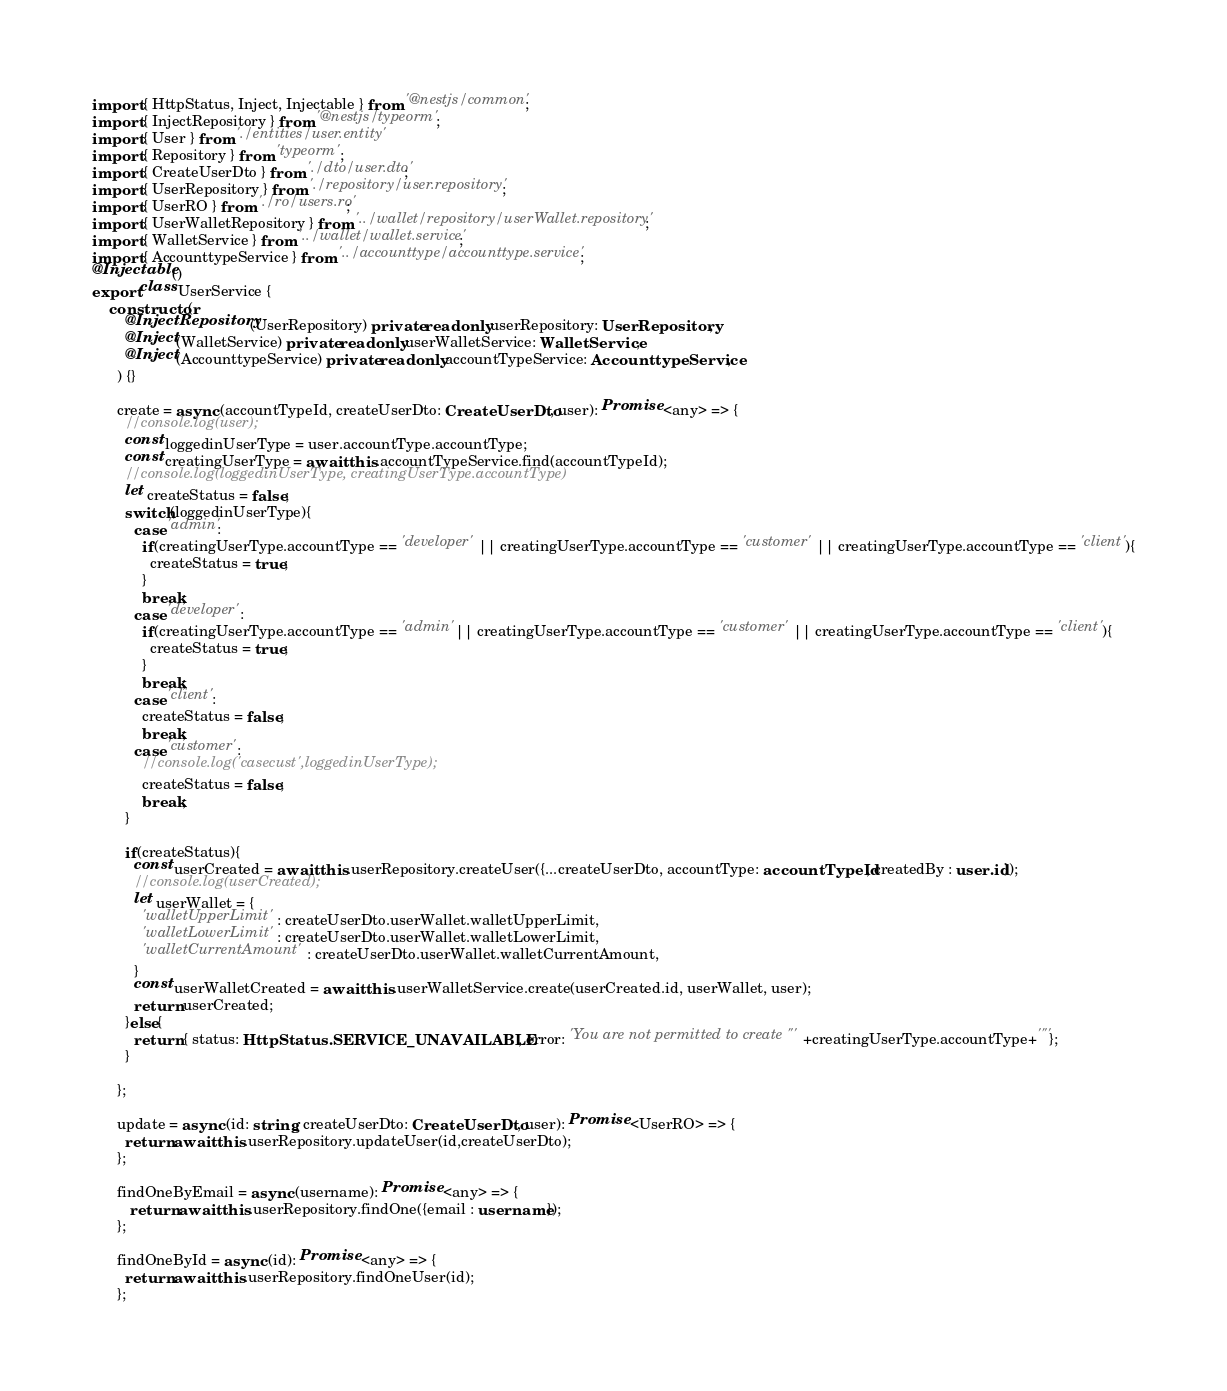<code> <loc_0><loc_0><loc_500><loc_500><_TypeScript_>

import { HttpStatus, Inject, Injectable } from '@nestjs/common';
import { InjectRepository } from '@nestjs/typeorm';
import { User } from './entities/user.entity'
import { Repository } from 'typeorm';
import { CreateUserDto } from './dto/user.dto';
import { UserRepository } from './repository/user.repository';
import { UserRO } from './ro/users.ro';
import { UserWalletRepository } from '../wallet/repository/userWallet.repository';
import { WalletService } from '../wallet/wallet.service';
import { AccounttypeService } from '../accounttype/accounttype.service';
@Injectable()
export class UserService {
    constructor(
        @InjectRepository(UserRepository) private readonly userRepository: UserRepository,
        @Inject(WalletService) private readonly userWalletService: WalletService,
        @Inject(AccounttypeService) private readonly accountTypeService: AccounttypeService,
      ) {}
      
      create = async (accountTypeId, createUserDto: CreateUserDto, user): Promise <any> => {
        //console.log(user);
        const loggedinUserType = user.accountType.accountType;
        const creatingUserType = await this.accountTypeService.find(accountTypeId);
        //console.log(loggedinUserType, creatingUserType.accountType)
        let createStatus = false;
        switch(loggedinUserType){
          case 'admin':
            if(creatingUserType.accountType == 'developer' || creatingUserType.accountType == 'customer' || creatingUserType.accountType == 'client'){
              createStatus = true;
            }
            break;
          case 'developer':
            if(creatingUserType.accountType == 'admin' || creatingUserType.accountType == 'customer' || creatingUserType.accountType == 'client'){
              createStatus = true;
            }
            break;
          case 'client':
            createStatus = false;
            break;
          case 'customer':
            //console.log('casecust',loggedinUserType);
            createStatus = false;
            break;
        }

        if(createStatus){
          const userCreated = await this.userRepository.createUser({...createUserDto, accountType: accountTypeId, createdBy : user.id});
          //console.log(userCreated);
          let userWallet = {
            'walletUpperLimit' : createUserDto.userWallet.walletUpperLimit,
            'walletLowerLimit' : createUserDto.userWallet.walletLowerLimit,
            'walletCurrentAmount' : createUserDto.userWallet.walletCurrentAmount,
          }
          const userWalletCreated = await this.userWalletService.create(userCreated.id, userWallet, user);
          return userCreated; 
        }else{
          return { status: HttpStatus.SERVICE_UNAVAILABLE, error: 'You are not permitted to create "'+creatingUserType.accountType+'"'};
        }
        
      };
    
      update = async (id: string, createUserDto: CreateUserDto, user): Promise <UserRO> => {
        return await this.userRepository.updateUser(id,createUserDto);
      };

      findOneByEmail = async (username): Promise <any> => {
         return await this.userRepository.findOne({email : username});
      };

      findOneById = async (id): Promise <any> => {
        return await this.userRepository.findOneUser(id);
      };
</code> 